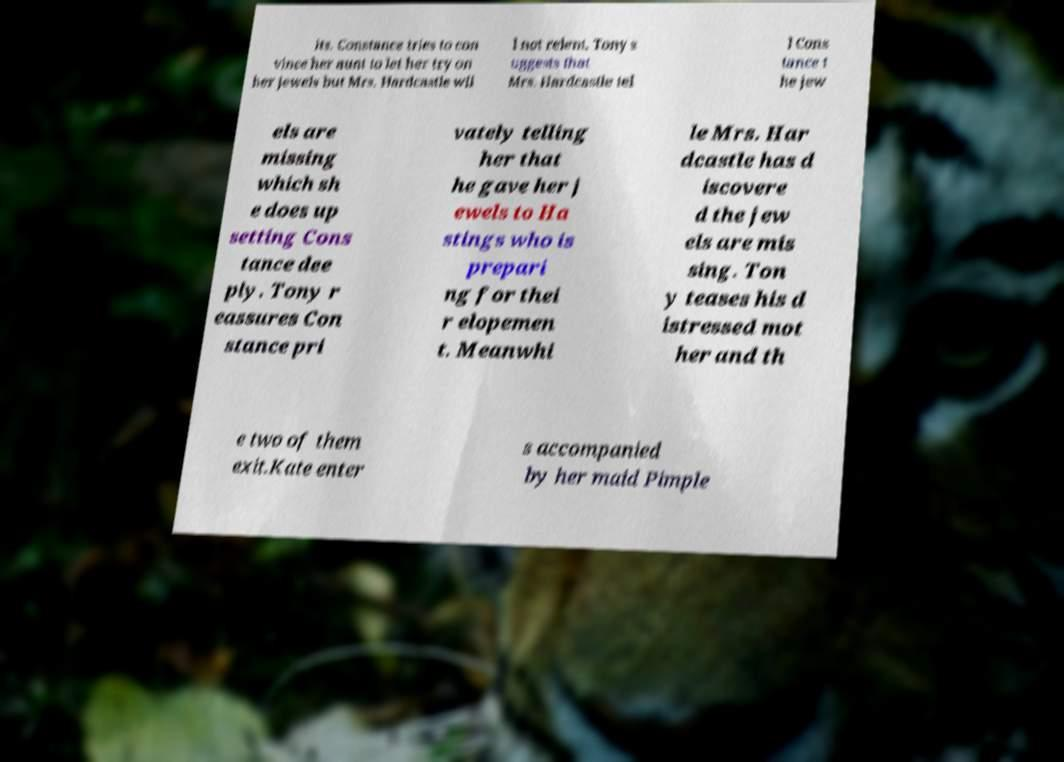There's text embedded in this image that I need extracted. Can you transcribe it verbatim? its. Constance tries to con vince her aunt to let her try on her jewels but Mrs. Hardcastle wil l not relent. Tony s uggests that Mrs. Hardcastle tel l Cons tance t he jew els are missing which sh e does up setting Cons tance dee ply. Tony r eassures Con stance pri vately telling her that he gave her j ewels to Ha stings who is prepari ng for thei r elopemen t. Meanwhi le Mrs. Har dcastle has d iscovere d the jew els are mis sing. Ton y teases his d istressed mot her and th e two of them exit.Kate enter s accompanied by her maid Pimple 